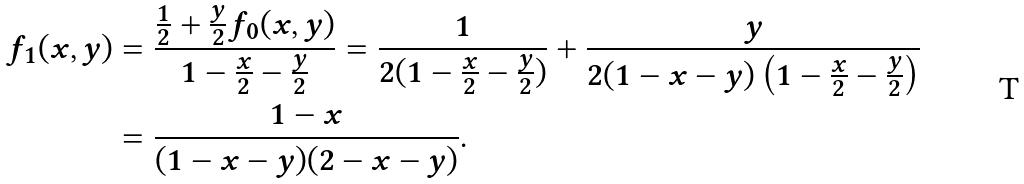Convert formula to latex. <formula><loc_0><loc_0><loc_500><loc_500>f _ { 1 } ( x , y ) & = \frac { \frac { 1 } { 2 } + \frac { y } 2 f _ { 0 } ( x , y ) } { 1 - \frac { x } 2 - \frac { y } 2 } = \frac { 1 } { 2 ( 1 - \frac { x } 2 - \frac { y } 2 ) } + \frac { y } { 2 ( 1 - x - y ) \left ( 1 - \frac { x } 2 - \frac { y } 2 \right ) } \\ & = \frac { 1 - x } { ( 1 - x - y ) ( 2 - x - y ) } .</formula> 